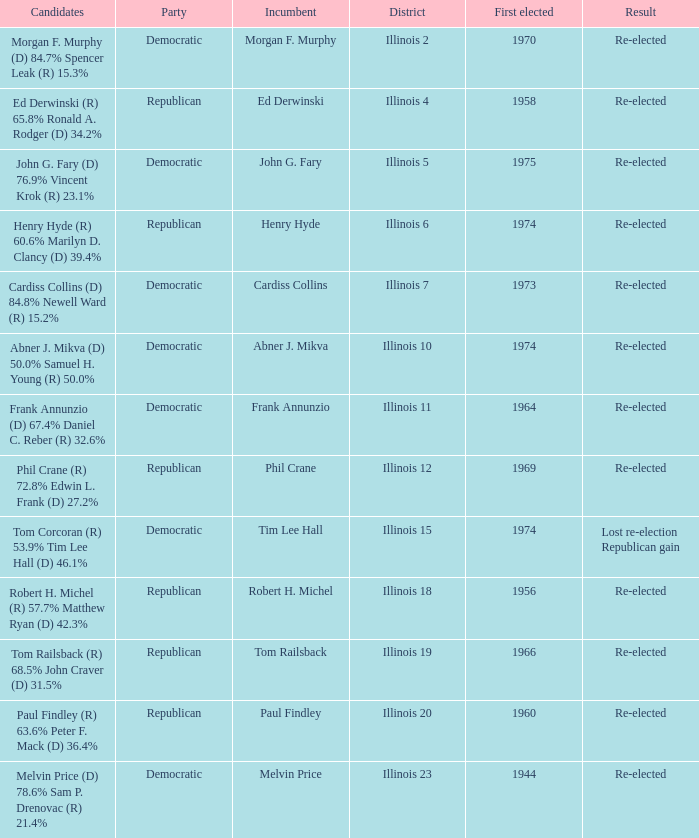Name the party for tim lee hall Democratic. 